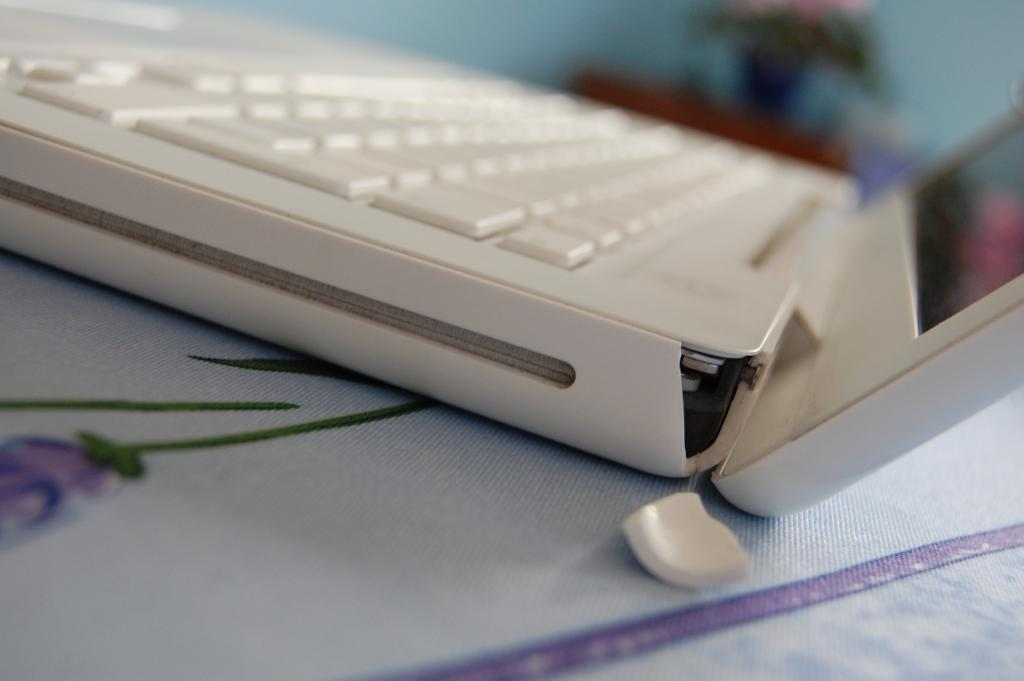What electronic device is in the center of the image? There is a laptop in the center of the image. Can you describe the background of the image? The background of the image is blurry. How many boats can be seen in the image? There are no boats present in the image. What type of legs are visible in the image? There are no legs visible in the image. 